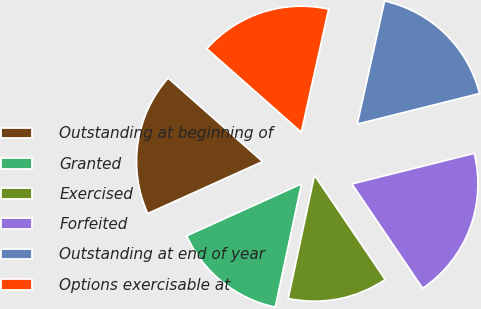Convert chart. <chart><loc_0><loc_0><loc_500><loc_500><pie_chart><fcel>Outstanding at beginning of<fcel>Granted<fcel>Exercised<fcel>Forfeited<fcel>Outstanding at end of year<fcel>Options exercisable at<nl><fcel>18.28%<fcel>14.9%<fcel>12.82%<fcel>19.42%<fcel>17.62%<fcel>16.96%<nl></chart> 